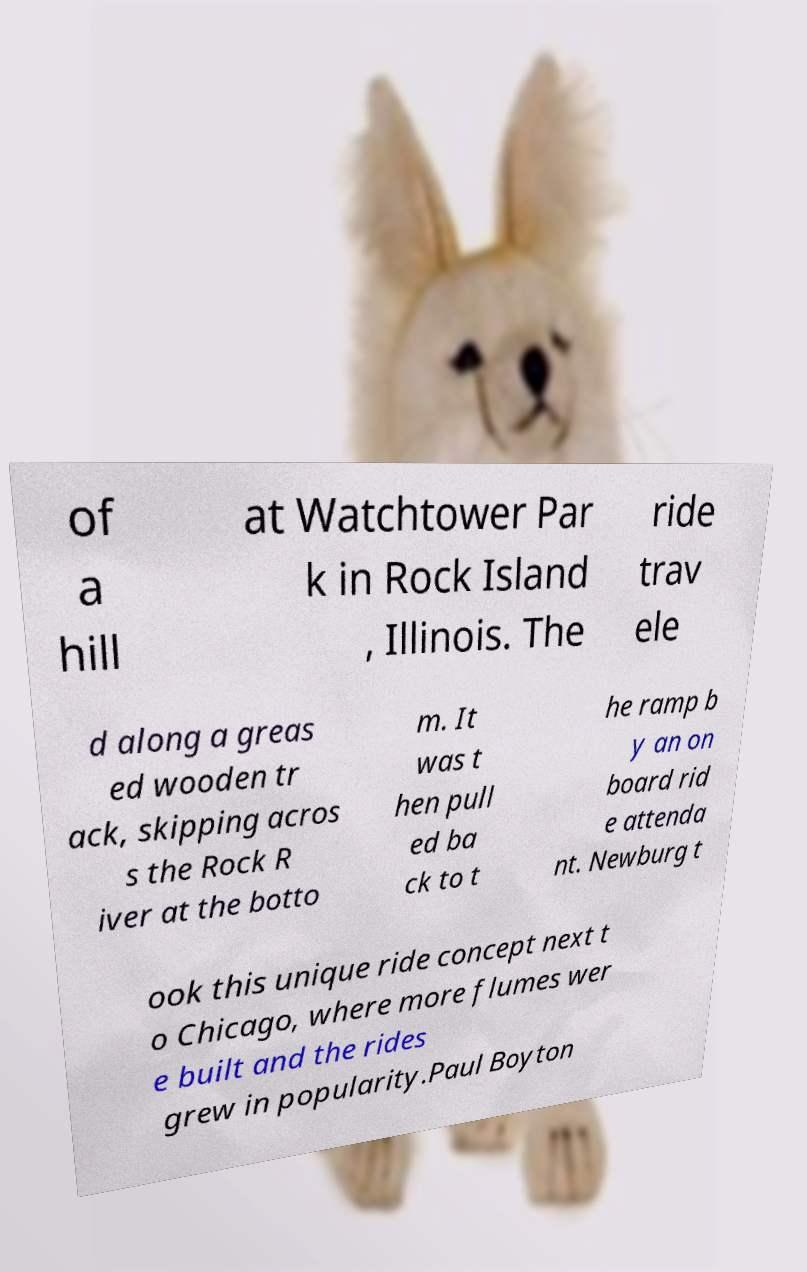For documentation purposes, I need the text within this image transcribed. Could you provide that? of a hill at Watchtower Par k in Rock Island , Illinois. The ride trav ele d along a greas ed wooden tr ack, skipping acros s the Rock R iver at the botto m. It was t hen pull ed ba ck to t he ramp b y an on board rid e attenda nt. Newburg t ook this unique ride concept next t o Chicago, where more flumes wer e built and the rides grew in popularity.Paul Boyton 